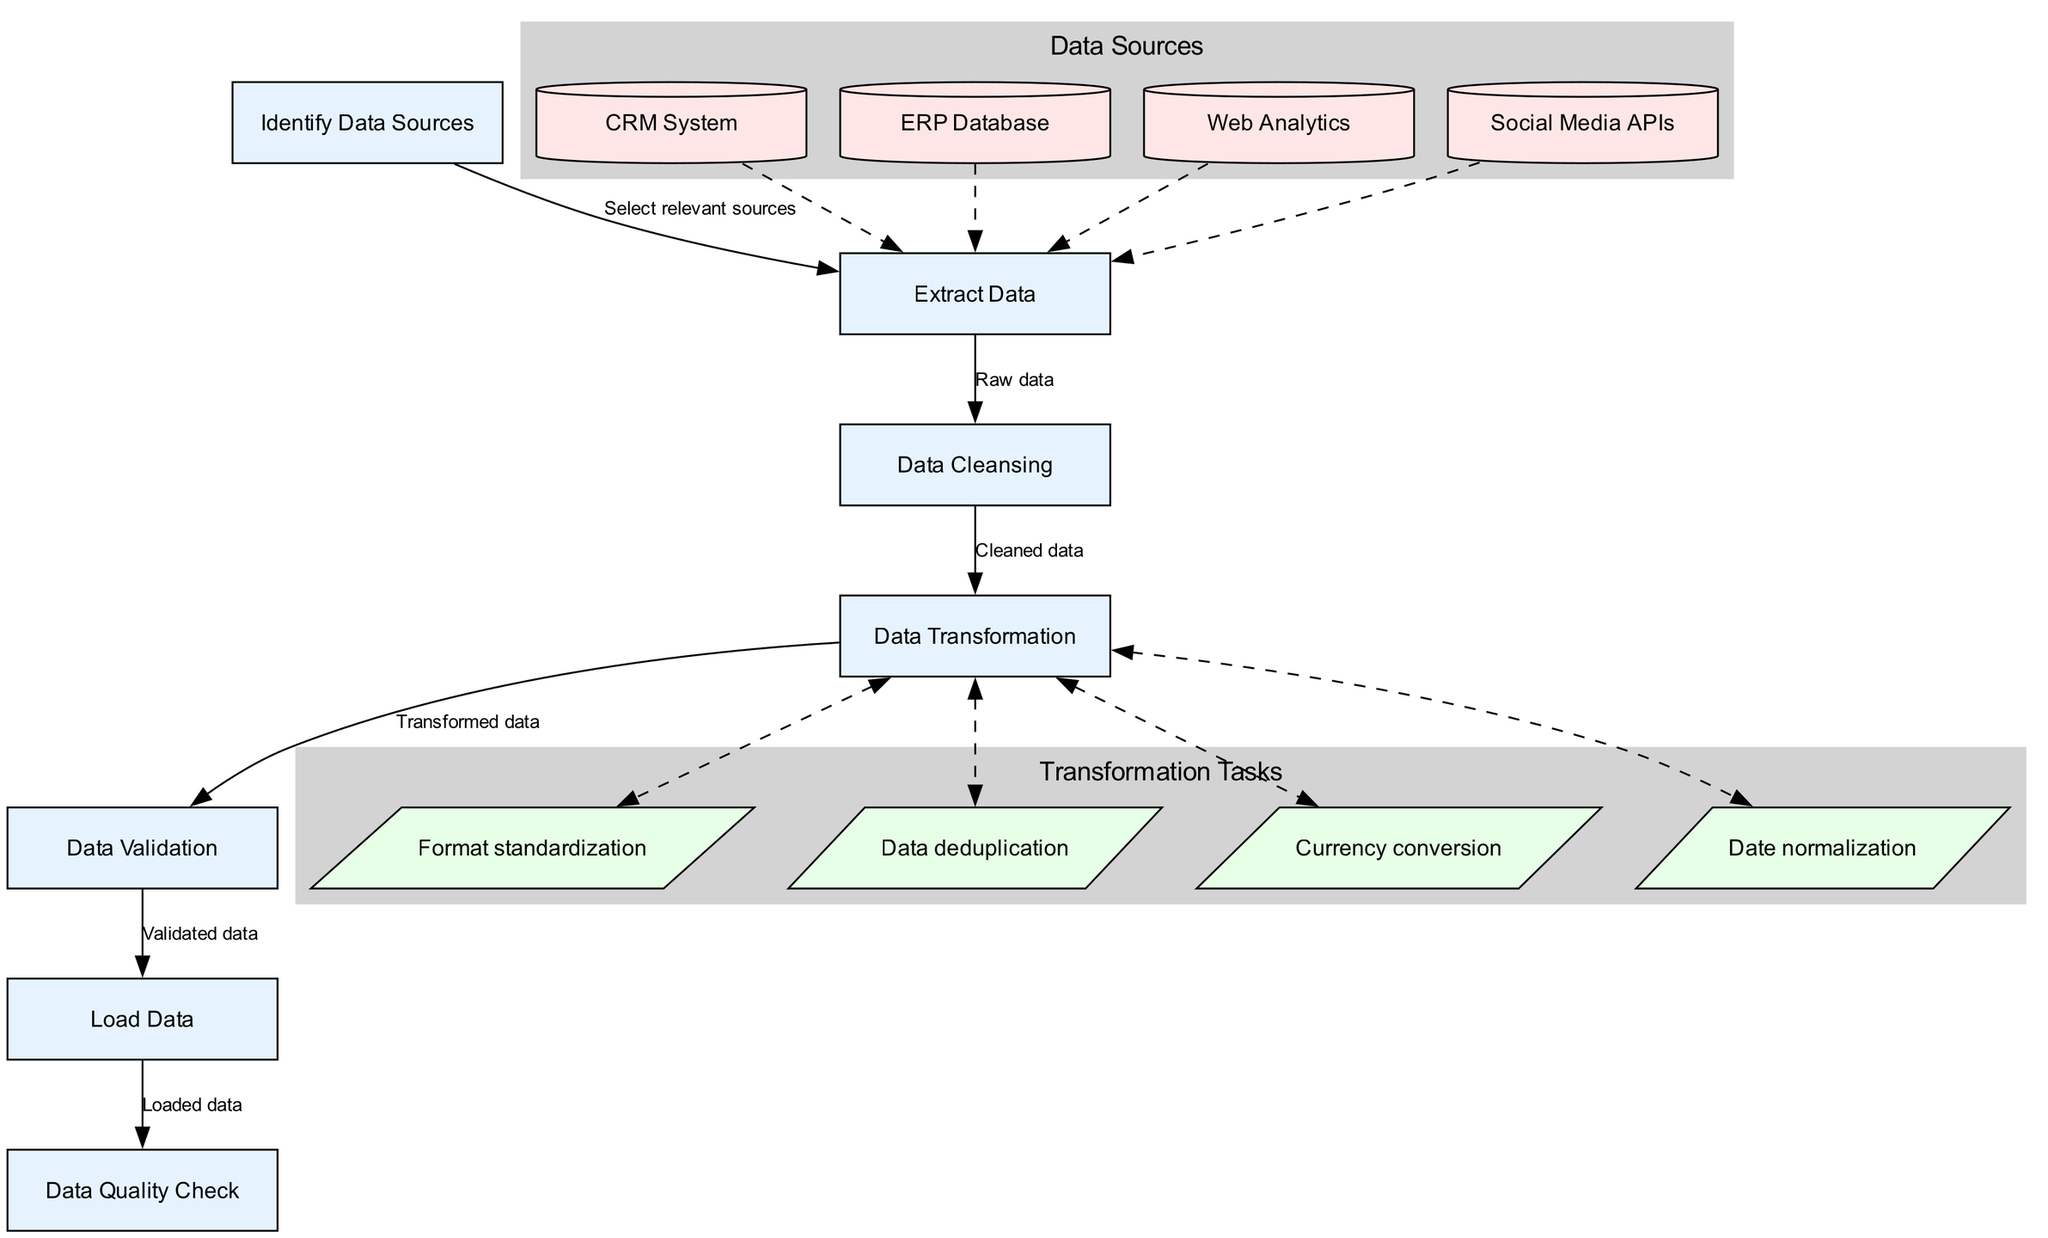What is the starting point of the ETL workflow? The starting point, or initial node, of the workflow is explicitly labeled as "Identify Data Sources" in the diagram. This indicates where the process begins.
Answer: Identify Data Sources How many transformation tasks are shown in the diagram? By counting the listed transformation tasks, we see there are four distinct tasks: "Format standardization," "Data deduplication," "Currency conversion," and "Date normalization." This results in a total of four tasks.
Answer: 4 Which node follows the "Data Cleansing" node? Upon analyzing the flow of the diagram, the "Data Transformation" node is directly connected to "Data Cleansing." This indicates that "Data Transformation" occurs immediately following "Data Cleansing."
Answer: Data Transformation What type of edges connect the data sources to the "Extract Data" node? The edges that connect the data sources to the "Extract Data" node are specifically styled as dashed, according to the edge styles defined in the diagram. This indicates a non-directive relationship.
Answer: Dashed Which two nodes have a direct relationship where the arrow points from "Data Validation" to "Load Data"? The relationship is direct from "Data Validation" to "Load Data," as indicated by the arrow that visually connects these two nodes within the diagram. This shows a sequential step in the ETL process.
Answer: Load Data What is the label on the edge leading from "Extract Data" to "Data Cleansing"? The label on this edge explicitly states "Raw data," indicating that the data being processed at this stage is in its original format, unrefined from its source.
Answer: Raw data What indicates that "Data Quality Check" comes after "Load Data"? The arrow that leads from "Load Data" to "Data Quality Check" signifies that this step follows the loading phase, making it clear that the quality check is performed after the data has been loaded.
Answer: Data Quality Check What are the visual styles used for the transformation tasks in the diagram? The transformation tasks are depicted with a parallelogram shape and filled with a light green color. This specific styling denotes them as distinct from other nodes within the ETL process.
Answer: Parallelogram How many nodes are displayed in total within the workflow? The total number of nodes includes the starting node, the transformation nodes, and the final node. Summing these gives us a grand total of seven distinct nodes in the workflow.
Answer: 7 